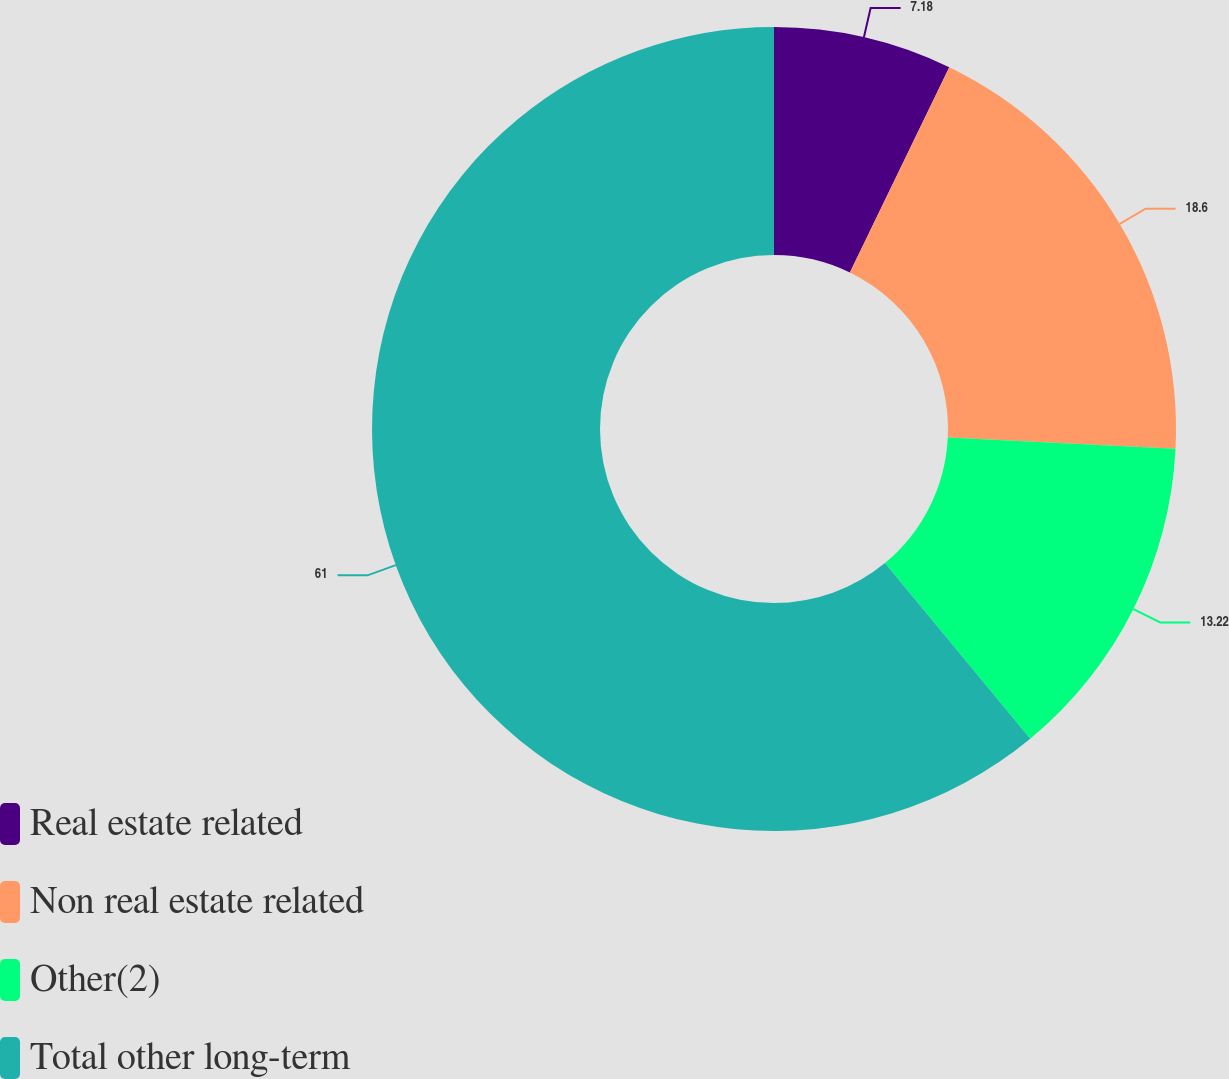<chart> <loc_0><loc_0><loc_500><loc_500><pie_chart><fcel>Real estate related<fcel>Non real estate related<fcel>Other(2)<fcel>Total other long-term<nl><fcel>7.18%<fcel>18.6%<fcel>13.22%<fcel>61.0%<nl></chart> 